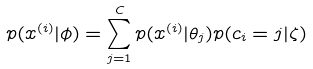<formula> <loc_0><loc_0><loc_500><loc_500>p ( x ^ { ( i ) } | \phi ) = \sum _ { j = 1 } ^ { C } p ( x ^ { ( i ) } | \theta _ { j } ) p ( c _ { i } = j | \zeta )</formula> 